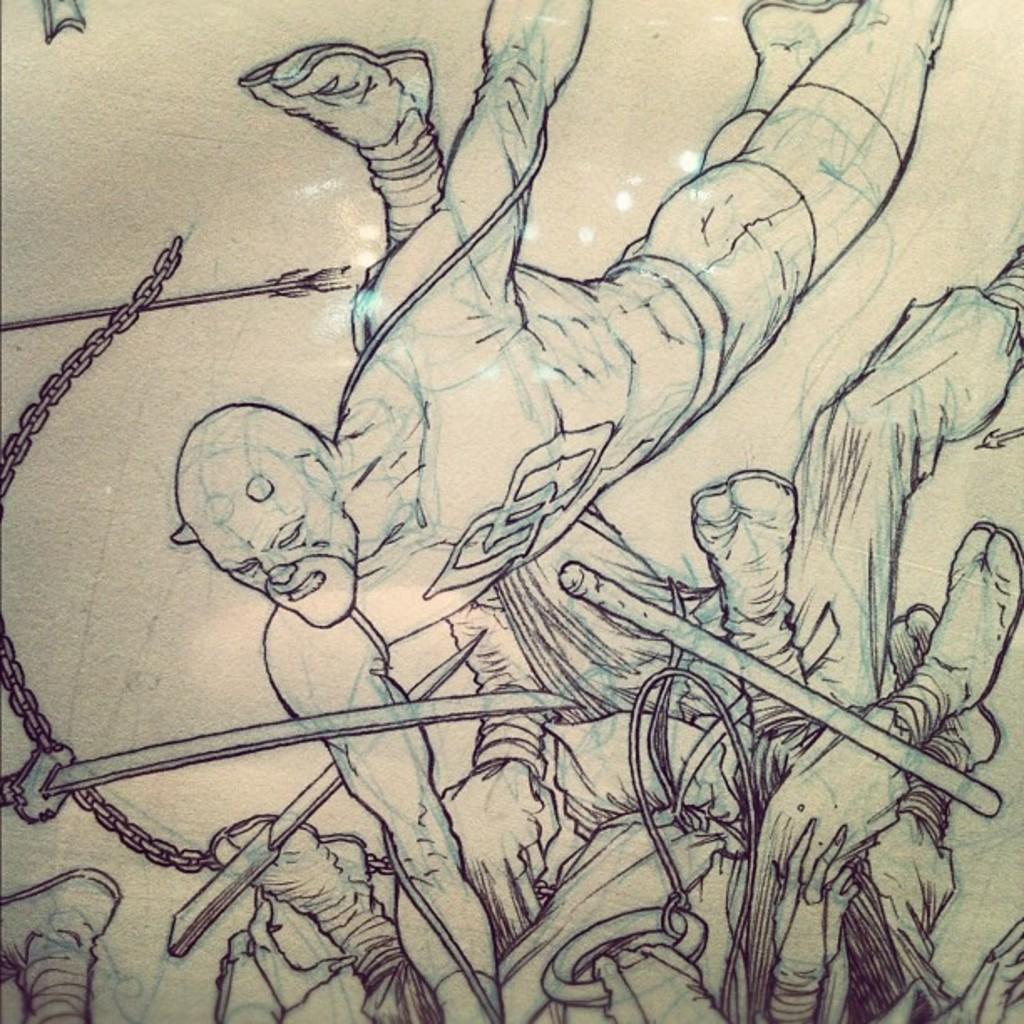In one or two sentences, can you explain what this image depicts? In the foreground of this sketch image, we can see knives, chain, arrow, people and the stick. 